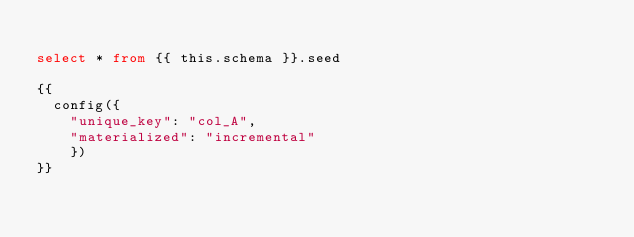<code> <loc_0><loc_0><loc_500><loc_500><_SQL_>
select * from {{ this.schema }}.seed

{{
  config({
    "unique_key": "col_A",
    "materialized": "incremental"
    })
}}
</code> 